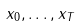<formula> <loc_0><loc_0><loc_500><loc_500>x _ { 0 } , \dots , x _ { T }</formula> 